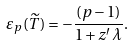Convert formula to latex. <formula><loc_0><loc_0><loc_500><loc_500>\varepsilon _ { p } ( \widetilde { T } ) = - \frac { ( p - 1 ) } { 1 + z ^ { \prime } \, \lambda } .</formula> 